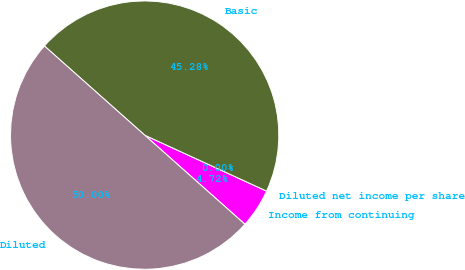Convert chart. <chart><loc_0><loc_0><loc_500><loc_500><pie_chart><fcel>Income from continuing<fcel>Diluted net income per share<fcel>Basic<fcel>Diluted<nl><fcel>4.72%<fcel>0.0%<fcel>45.28%<fcel>50.0%<nl></chart> 